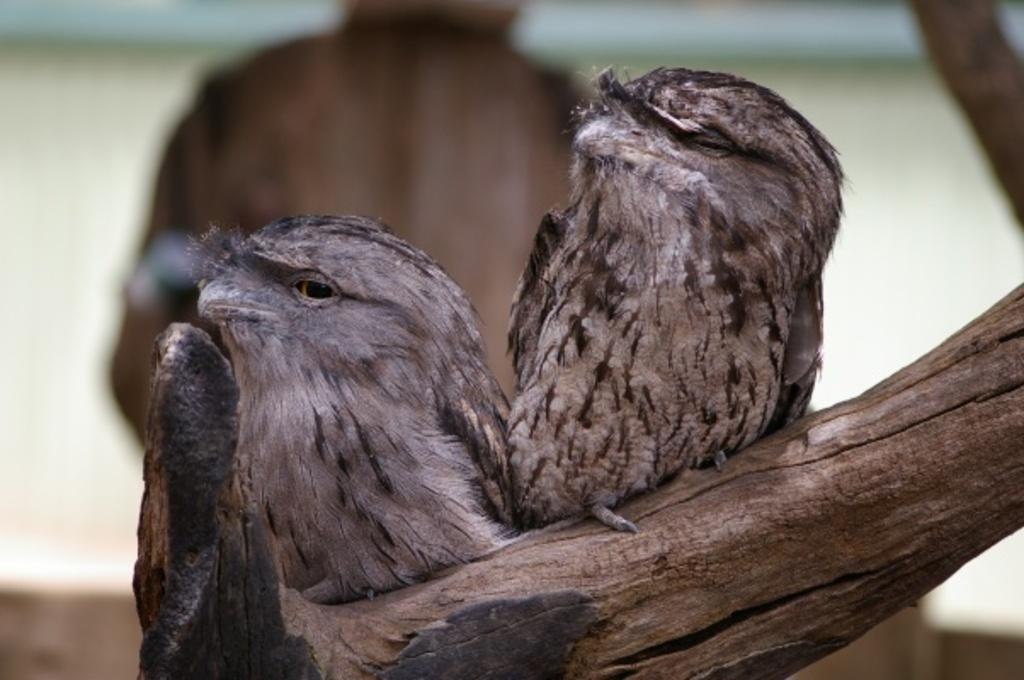What animals can be seen in the image? There are two birds on the branch of a tree. Can you describe the setting of the image? There is a person standing in the background, and the background is blurry. What type of door can be seen in the image? There is no door present in the image; it features two birds on a tree branch and a person in the background. 